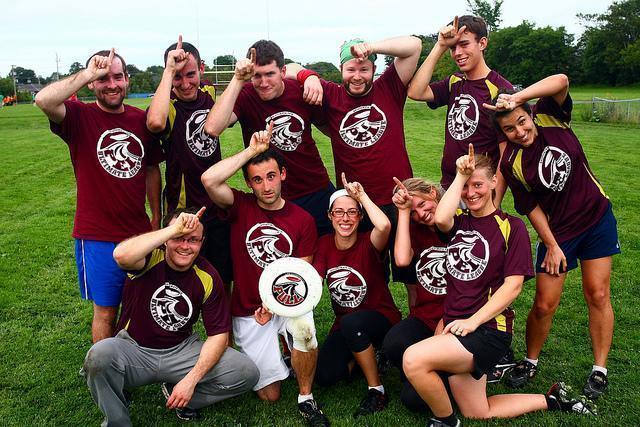What is the finger everyone is holding up commonly called?
Select the accurate answer and provide justification: `Answer: choice
Rationale: srationale.`
Options: Big finger, ring finger, index finger, thrust finger. Answer: index finger.
Rationale: People are pointing their second fingers. 